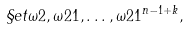Convert formula to latex. <formula><loc_0><loc_0><loc_500><loc_500>\S e t { \omega 2 , \omega 2 1 , \dots , \omega 2 1 ^ { n - 1 + k } } ,</formula> 